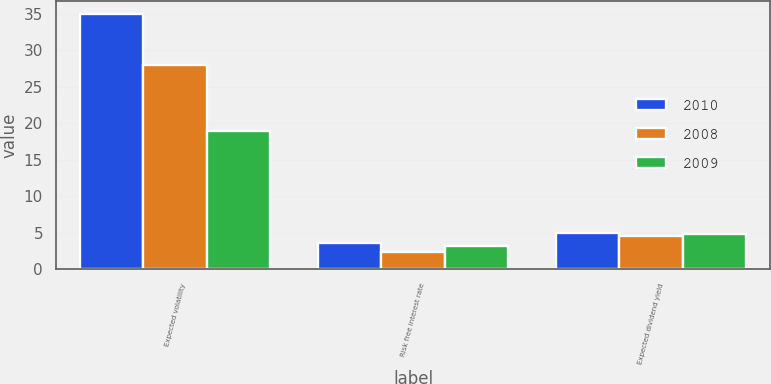<chart> <loc_0><loc_0><loc_500><loc_500><stacked_bar_chart><ecel><fcel>Expected volatility<fcel>Risk free interest rate<fcel>Expected dividend yield<nl><fcel>2010<fcel>35<fcel>3.6<fcel>4.9<nl><fcel>2008<fcel>28<fcel>2.3<fcel>4.6<nl><fcel>2009<fcel>19<fcel>3.2<fcel>4.8<nl></chart> 